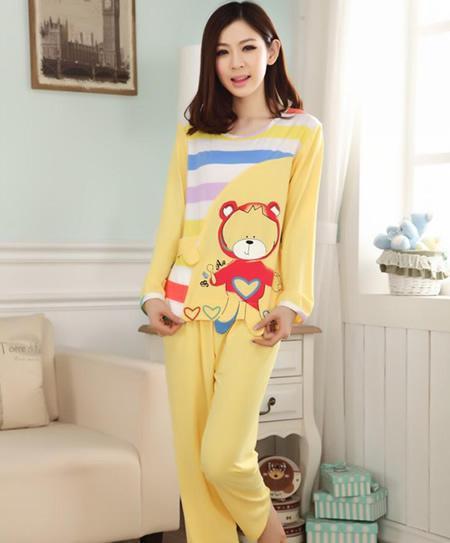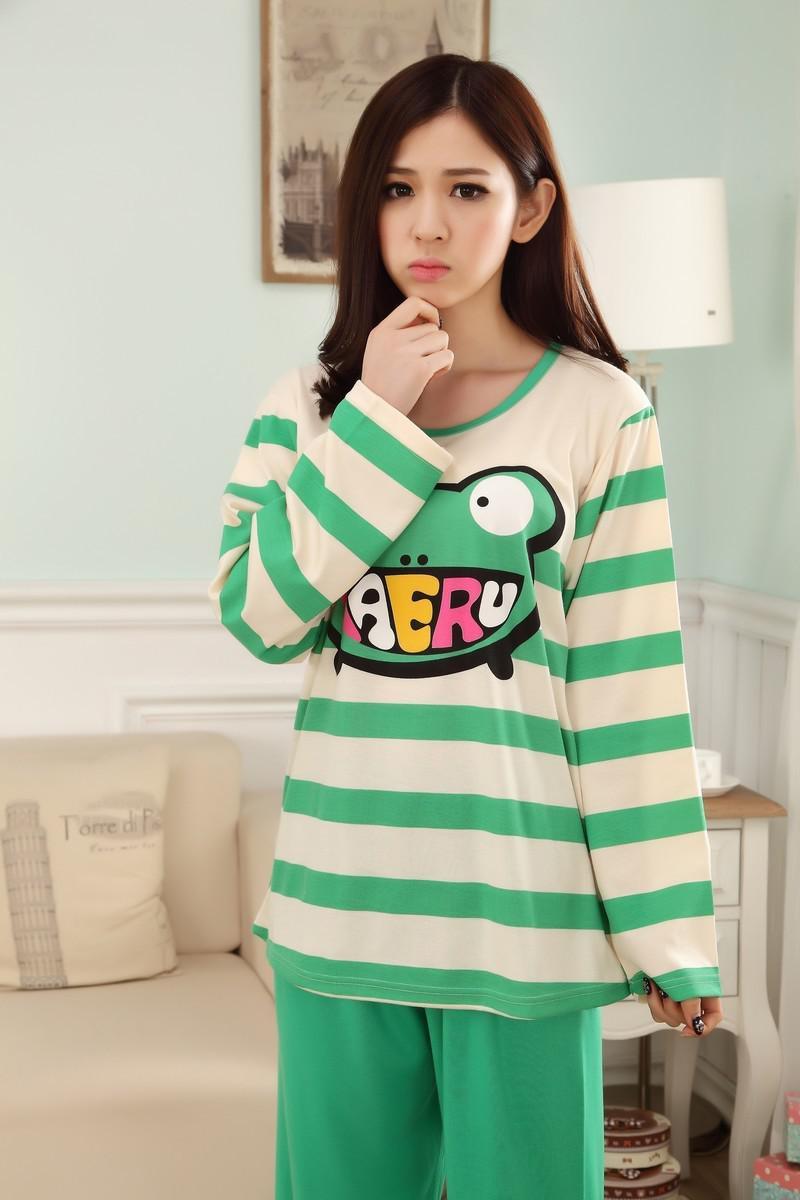The first image is the image on the left, the second image is the image on the right. Given the left and right images, does the statement "Both girls are standing up but only one of them is touching her face." hold true? Answer yes or no. Yes. The first image is the image on the left, the second image is the image on the right. Examine the images to the left and right. Is the description "All of the girls are wearing pajamas with cartoon characters on them." accurate? Answer yes or no. Yes. 